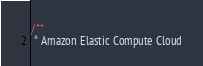<code> <loc_0><loc_0><loc_500><loc_500><_JavaScript_>/**
 * Amazon Elastic Compute Cloud</code> 